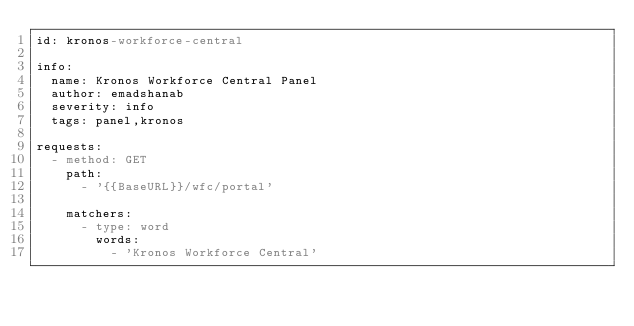<code> <loc_0><loc_0><loc_500><loc_500><_YAML_>id: kronos-workforce-central

info:
  name: Kronos Workforce Central Panel
  author: emadshanab
  severity: info
  tags: panel,kronos

requests:
  - method: GET
    path:
      - '{{BaseURL}}/wfc/portal'

    matchers:
      - type: word
        words:
          - 'Kronos Workforce Central'
</code> 